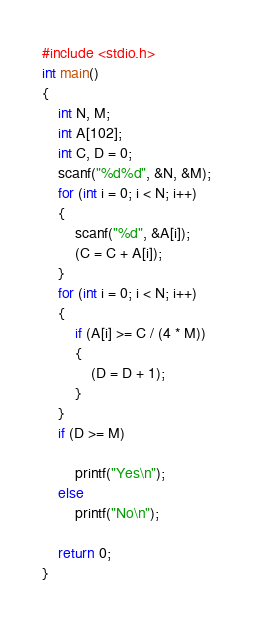Convert code to text. <code><loc_0><loc_0><loc_500><loc_500><_C_>#include <stdio.h>
int main()
{
    int N, M;
    int A[102];
    int C, D = 0;
    scanf("%d%d", &N, &M);
    for (int i = 0; i < N; i++)
    {
        scanf("%d", &A[i]);
        (C = C + A[i]);
    }
    for (int i = 0; i < N; i++)
    {
        if (A[i] >= C / (4 * M))
        {
            (D = D + 1);
        }
    }
    if (D >= M)

        printf("Yes\n");
    else
        printf("No\n");

    return 0;
}</code> 